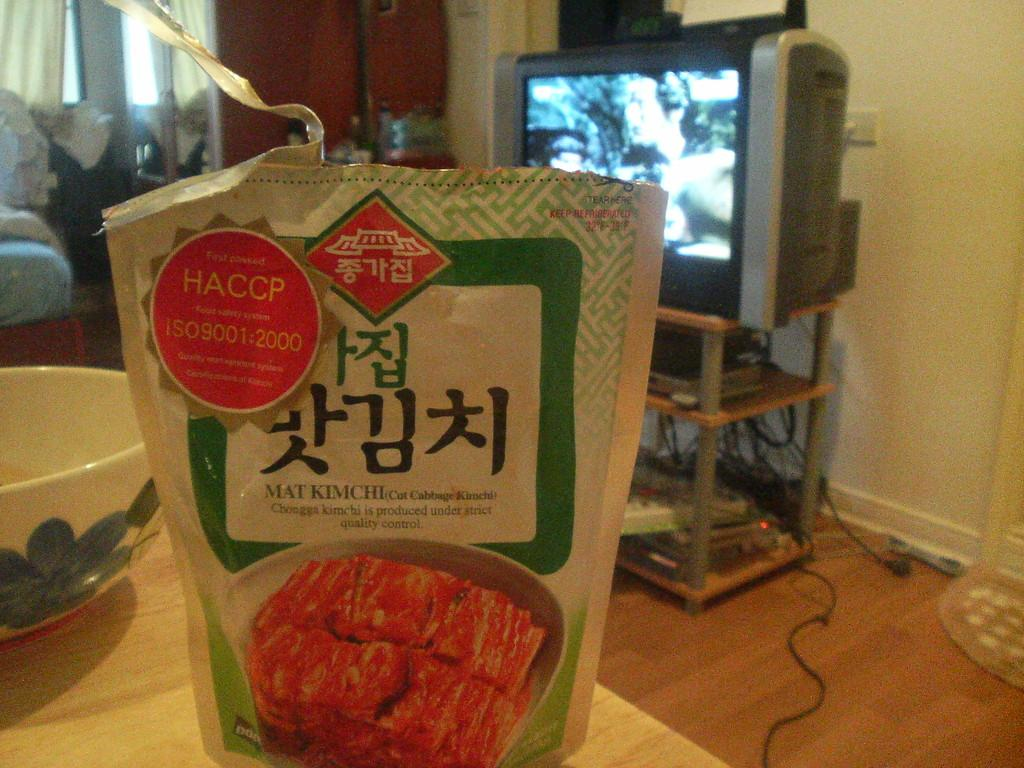<image>
Share a concise interpretation of the image provided. A bag for a packaged meat product with Asian writing on it. 